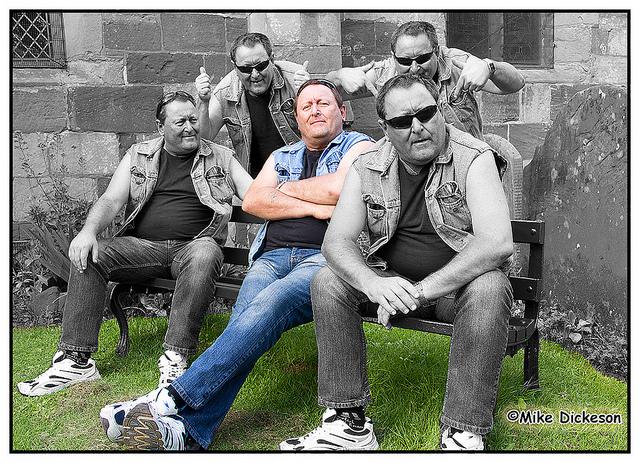Is it the same man pictured 5 times?
Short answer required. Yes. How many images of the man are black and white?
Keep it brief. 4. How many men in the picture are wearing sunglasses?
Be succinct. 3. 